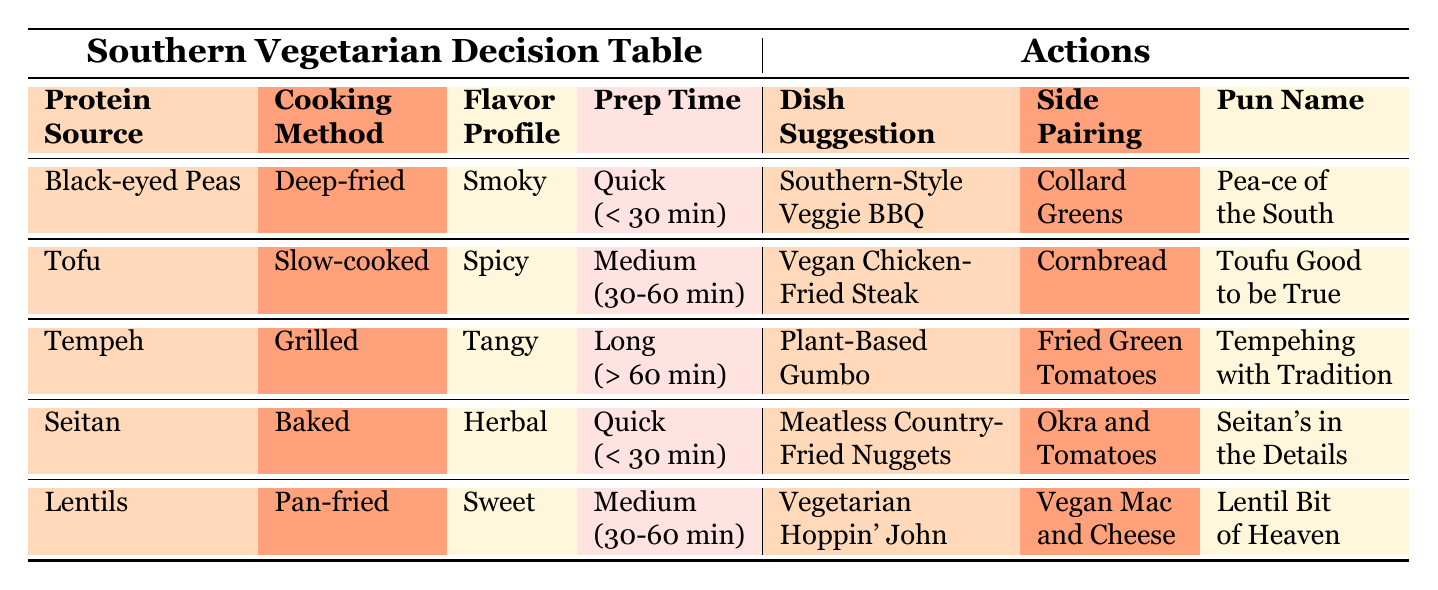What is the protein source used in the Southern-Style Veggie BBQ? According to the table, the Southern-Style Veggie BBQ is paired with Black-eyed Peas as the protein source.
Answer: Black-eyed Peas Which dish suggestion requires slow cooking and has a spicy flavor profile? The table shows that the dish suggested for the Cooking Method "Slow-cooked" and Flavor Profile "Spicy" is Vegan Chicken-Fried Steak.
Answer: Vegan Chicken-Fried Steak True or False: Collard Greens is paired with Lentils in any dish suggestion. In the table, Collard Greens is only paired with the Southern-Style Veggie BBQ, which uses Black-eyed Peas, and no pairing is found with Lentils.
Answer: False What is the common cooking method for both Plant-Based Gumbo and Vegetarian Hoppin' John? Upon inspecting the table, Plant-Based Gumbo requires the Grilled cooking method, while Vegetarian Hoppin' John requires Pan-frying. Therefore, they do not share the same cooking method.
Answer: None What is the average preparation time for the dishes suggested in the table? The dishes suggested have the following preparation times: Quick (< 30 min) for 2 dishes, Medium (30-60 min) for 2 dishes, and Long (> 60 min) for 1 dish. To find the average, assign values: Quick=1, Medium=2, Long=3. So, (1 + 2 + 1 + 2 + 3) / 5 = 1.8, which corresponds to a Medium time.
Answer: Medium (30-60 min) Which pun-tastic dish name is associated with Tofu? The table indicates that the pun-tastic dish name related to Tofu is "Toufu Good to be True."
Answer: Toufu Good to be True If you want a dish that is deep-fried and has a smoky flavor, what dish suggestion would you choose? The table specifies that the dish suggestion for Deep-fried cooking and Smoky flavor profile is Southern-Style Veggie BBQ.
Answer: Southern-Style Veggie BBQ True or False: All dishes suggested are paired with a side dish. The table shows that every dish suggestion is indeed paired with a side dish, confirming that this statement is true.
Answer: True 